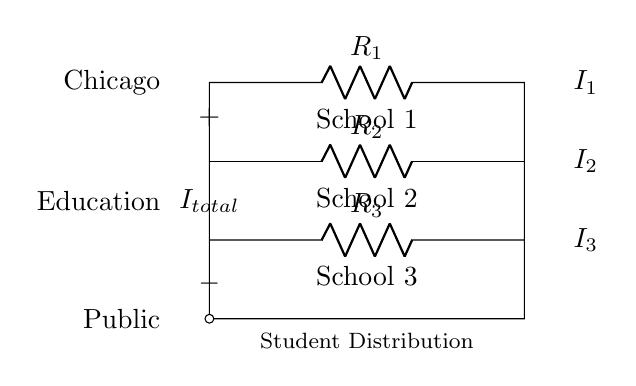What components are present in this circuit? The diagram shows three resistors labeled R1, R2, and R3. These resistors represent schools.
Answer: R1, R2, R3 What is the total current denoted in the circuit? The total current is indicated by the label I at the top of the circuit diagram.
Answer: I total Which school has the lowest resistance? Resistance values are typically indicated by the size of the resistor symbol; therefore, the school with the resistor marked R1 likely has the lowest resistance among R2 and R3.
Answer: R1 How is the current flowing through each school represented? The circuit diagram labels the currents flowing through each resistor with I1, I2, and I3, indicating the distribution of the total current among the three schools.
Answer: I1, I2, I3 What principle does this circuit demonstrate regarding electricity and student distribution? The circuit illustrates the current divider principle, which states that the total current entering a parallel resistor network is divided among the paths based on their resistance, akin to how students are distributed among different schools.
Answer: Current Divider Principle 